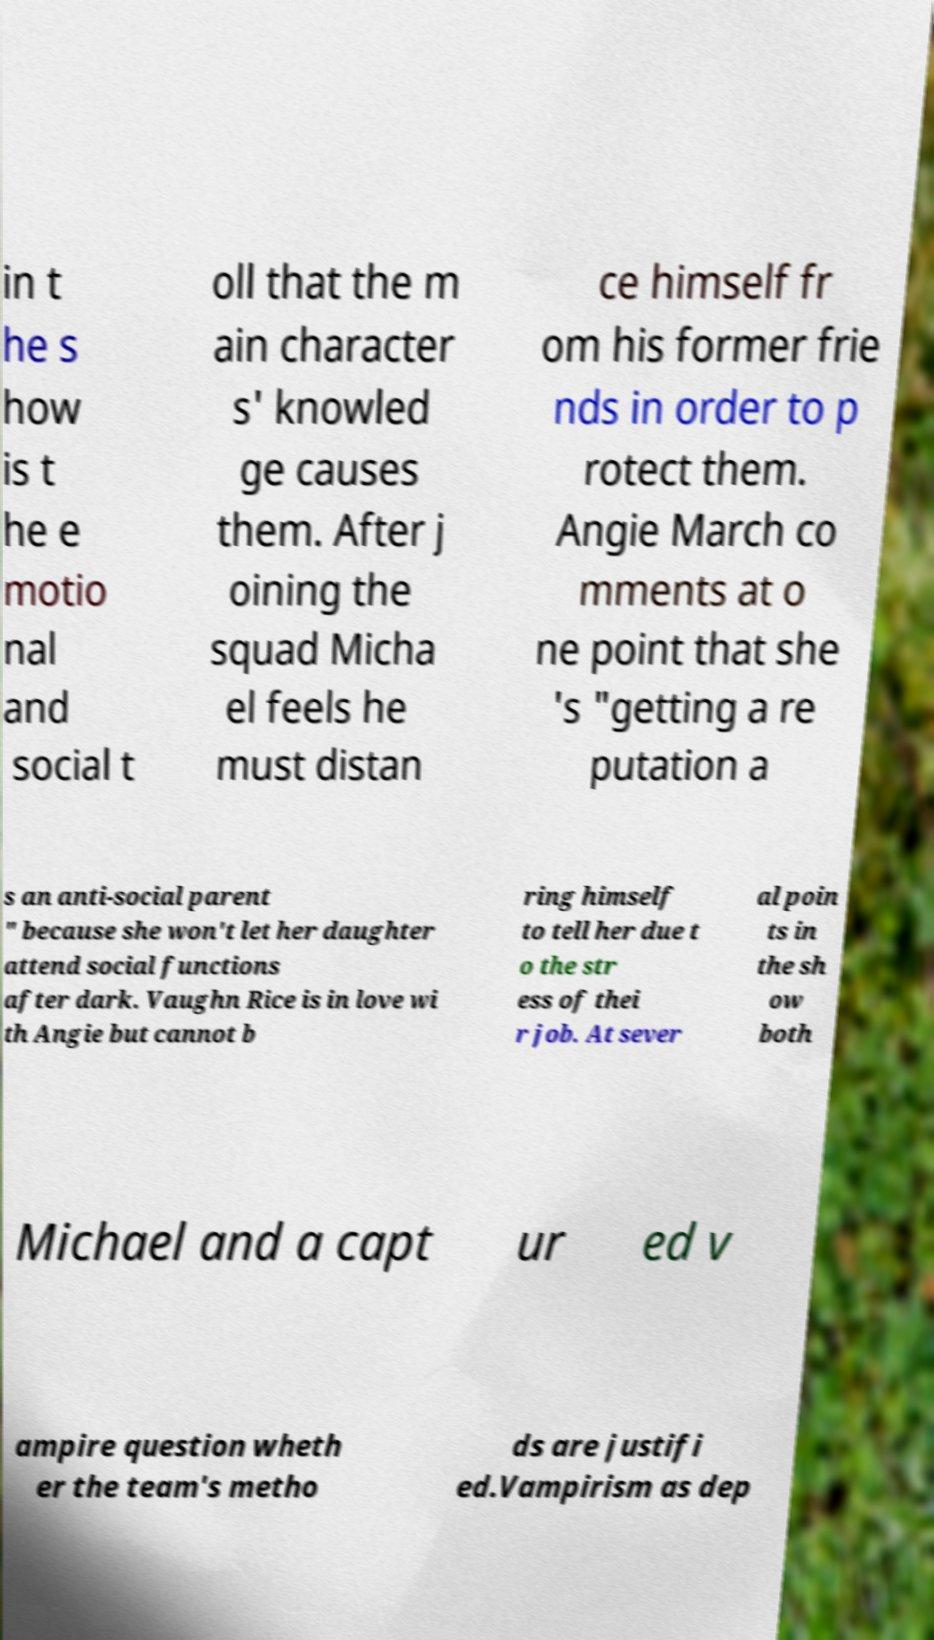Please read and relay the text visible in this image. What does it say? in t he s how is t he e motio nal and social t oll that the m ain character s' knowled ge causes them. After j oining the squad Micha el feels he must distan ce himself fr om his former frie nds in order to p rotect them. Angie March co mments at o ne point that she 's "getting a re putation a s an anti-social parent " because she won't let her daughter attend social functions after dark. Vaughn Rice is in love wi th Angie but cannot b ring himself to tell her due t o the str ess of thei r job. At sever al poin ts in the sh ow both Michael and a capt ur ed v ampire question wheth er the team's metho ds are justifi ed.Vampirism as dep 